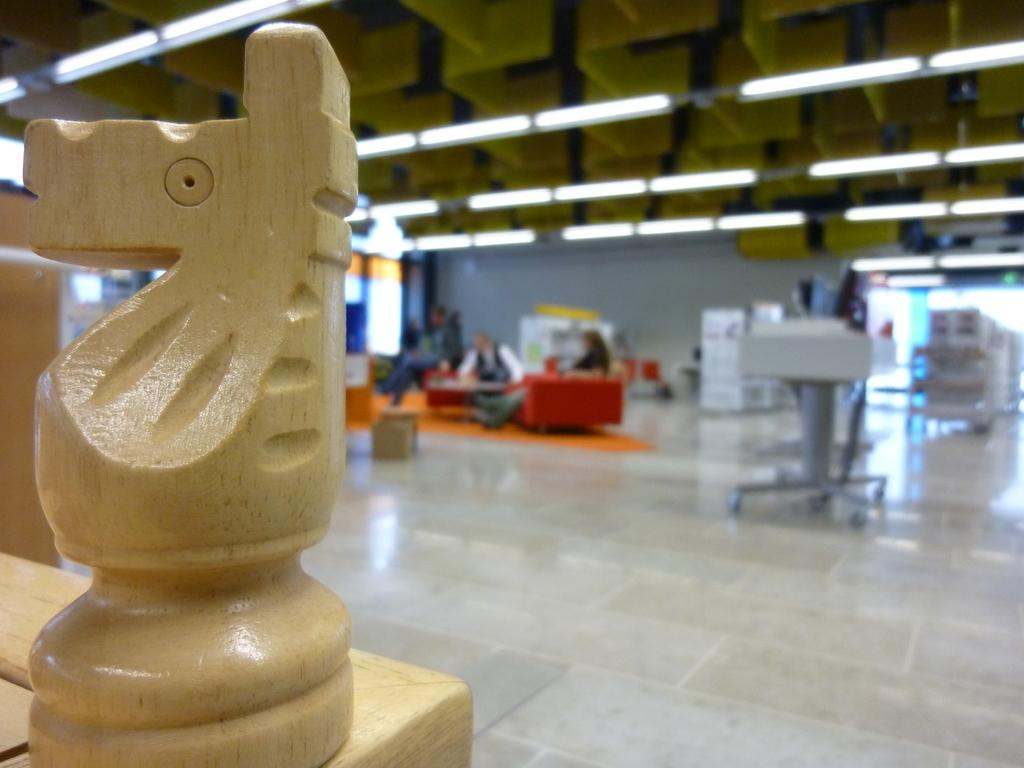What type of object is on the table in the image? There is a wooden object on the table in the image. Can you describe the background of the image? The background of the image is blurry. What part of the room can be seen in the image? The floor is visible in the image. What else can be seen in the background of the image? There are people and objects present in the background of the image. What is visible at the top of the image? Lights are visible at the top of the image. What type of wine is being served in the image? There is no wine present in the image; it only features a wooden object on the table and a blurry background with people and objects. 